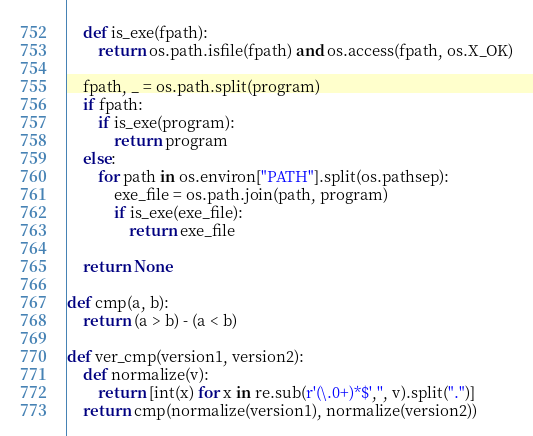<code> <loc_0><loc_0><loc_500><loc_500><_Python_>    def is_exe(fpath):
        return os.path.isfile(fpath) and os.access(fpath, os.X_OK)

    fpath, _ = os.path.split(program)
    if fpath:
        if is_exe(program):
            return program
    else:
        for path in os.environ["PATH"].split(os.pathsep):
            exe_file = os.path.join(path, program)
            if is_exe(exe_file):
                return exe_file

    return None

def cmp(a, b):
    return (a > b) - (a < b) 

def ver_cmp(version1, version2):
    def normalize(v):
        return [int(x) for x in re.sub(r'(\.0+)*$','', v).split(".")]
    return cmp(normalize(version1), normalize(version2))</code> 